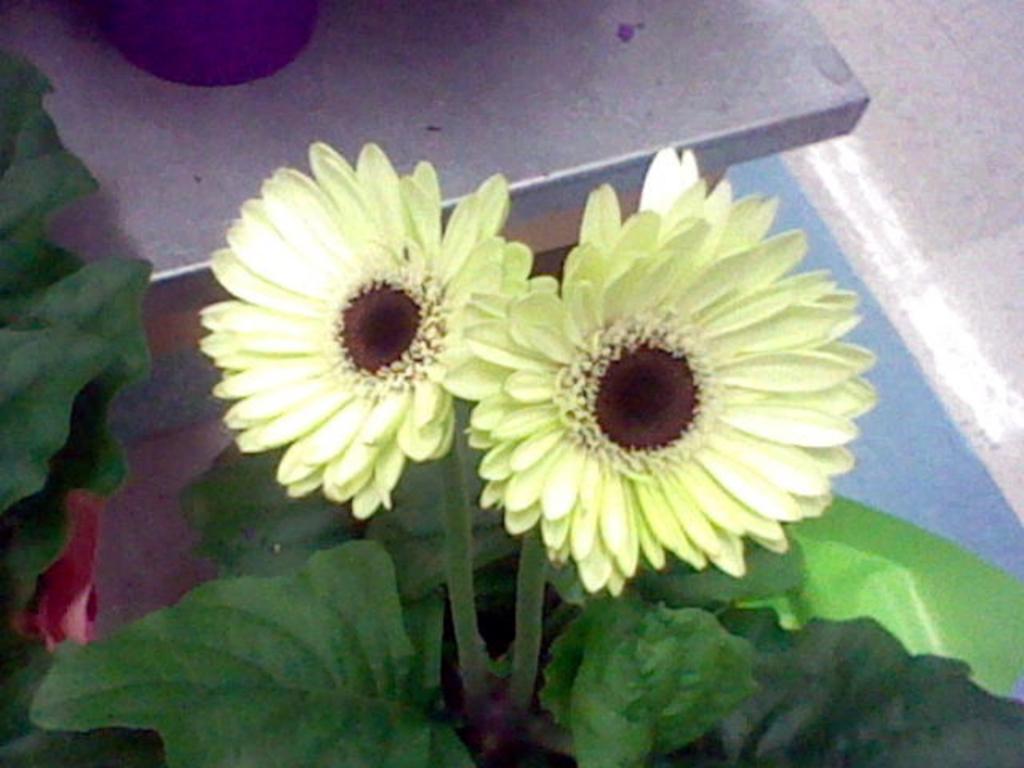Describe this image in one or two sentences. In this picture I can see flowers and plants in the middle. 